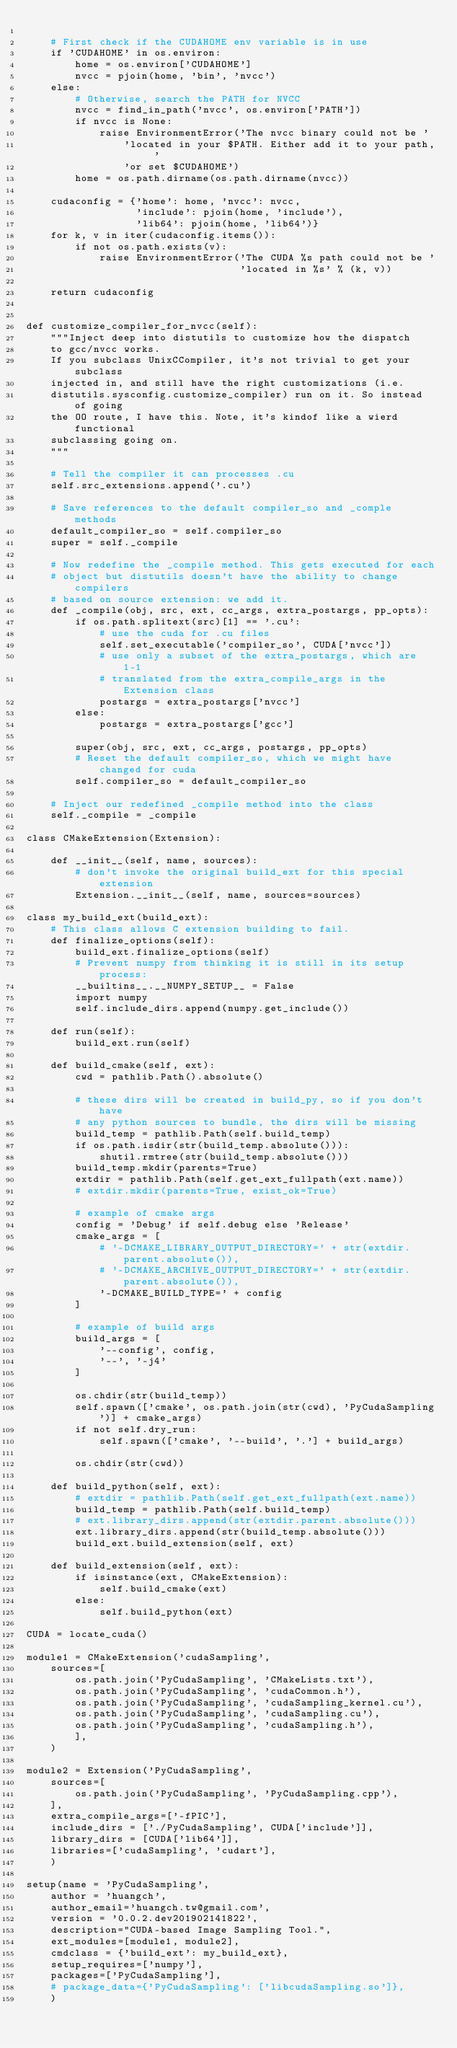Convert code to text. <code><loc_0><loc_0><loc_500><loc_500><_Python_>
    # First check if the CUDAHOME env variable is in use
    if 'CUDAHOME' in os.environ:
        home = os.environ['CUDAHOME']
        nvcc = pjoin(home, 'bin', 'nvcc')
    else:
        # Otherwise, search the PATH for NVCC
        nvcc = find_in_path('nvcc', os.environ['PATH'])
        if nvcc is None:
            raise EnvironmentError('The nvcc binary could not be '
                'located in your $PATH. Either add it to your path, '
                'or set $CUDAHOME')
        home = os.path.dirname(os.path.dirname(nvcc))

    cudaconfig = {'home': home, 'nvcc': nvcc,
                  'include': pjoin(home, 'include'),
                  'lib64': pjoin(home, 'lib64')}
    for k, v in iter(cudaconfig.items()):
        if not os.path.exists(v):
            raise EnvironmentError('The CUDA %s path could not be '
                                   'located in %s' % (k, v))

    return cudaconfig


def customize_compiler_for_nvcc(self):
    """Inject deep into distutils to customize how the dispatch
    to gcc/nvcc works.
    If you subclass UnixCCompiler, it's not trivial to get your subclass
    injected in, and still have the right customizations (i.e.
    distutils.sysconfig.customize_compiler) run on it. So instead of going
    the OO route, I have this. Note, it's kindof like a wierd functional
    subclassing going on.
    """

    # Tell the compiler it can processes .cu
    self.src_extensions.append('.cu')

    # Save references to the default compiler_so and _comple methods
    default_compiler_so = self.compiler_so
    super = self._compile

    # Now redefine the _compile method. This gets executed for each
    # object but distutils doesn't have the ability to change compilers
    # based on source extension: we add it.
    def _compile(obj, src, ext, cc_args, extra_postargs, pp_opts):
        if os.path.splitext(src)[1] == '.cu':
            # use the cuda for .cu files
            self.set_executable('compiler_so', CUDA['nvcc'])
            # use only a subset of the extra_postargs, which are 1-1
            # translated from the extra_compile_args in the Extension class
            postargs = extra_postargs['nvcc']
        else:
            postargs = extra_postargs['gcc']

        super(obj, src, ext, cc_args, postargs, pp_opts)
        # Reset the default compiler_so, which we might have changed for cuda
        self.compiler_so = default_compiler_so

    # Inject our redefined _compile method into the class
    self._compile = _compile
    
class CMakeExtension(Extension):

    def __init__(self, name, sources):
        # don't invoke the original build_ext for this special extension
        Extension.__init__(self, name, sources=sources)

class my_build_ext(build_ext):
    # This class allows C extension building to fail.
    def finalize_options(self):
        build_ext.finalize_options(self)
        # Prevent numpy from thinking it is still in its setup process:
        __builtins__.__NUMPY_SETUP__ = False
        import numpy
        self.include_dirs.append(numpy.get_include())

    def run(self):
        build_ext.run(self)

    def build_cmake(self, ext):
        cwd = pathlib.Path().absolute()

        # these dirs will be created in build_py, so if you don't have
        # any python sources to bundle, the dirs will be missing
        build_temp = pathlib.Path(self.build_temp)
        if os.path.isdir(str(build_temp.absolute())):
            shutil.rmtree(str(build_temp.absolute()))
        build_temp.mkdir(parents=True)
        extdir = pathlib.Path(self.get_ext_fullpath(ext.name))
        # extdir.mkdir(parents=True, exist_ok=True)

        # example of cmake args
        config = 'Debug' if self.debug else 'Release'
        cmake_args = [
            # '-DCMAKE_LIBRARY_OUTPUT_DIRECTORY=' + str(extdir.parent.absolute()),
            # '-DCMAKE_ARCHIVE_OUTPUT_DIRECTORY=' + str(extdir.parent.absolute()),
            '-DCMAKE_BUILD_TYPE=' + config
        ]

        # example of build args
        build_args = [
            '--config', config,
            '--', '-j4'
        ]

        os.chdir(str(build_temp))        
        self.spawn(['cmake', os.path.join(str(cwd), 'PyCudaSampling')] + cmake_args)
        if not self.dry_run:
            self.spawn(['cmake', '--build', '.'] + build_args)
            
        os.chdir(str(cwd))
        
    def build_python(self, ext):
        # extdir = pathlib.Path(self.get_ext_fullpath(ext.name))
        build_temp = pathlib.Path(self.build_temp)
        # ext.library_dirs.append(str(extdir.parent.absolute()))
        ext.library_dirs.append(str(build_temp.absolute()))
        build_ext.build_extension(self, ext)
        
    def build_extension(self, ext):
        if isinstance(ext, CMakeExtension):
            self.build_cmake(ext)
        else:
            self.build_python(ext)
      
CUDA = locate_cuda()

module1 = CMakeExtension('cudaSampling',
    sources=[
        os.path.join('PyCudaSampling', 'CMakeLists.txt'),
        os.path.join('PyCudaSampling', 'cudaCommon.h'),
        os.path.join('PyCudaSampling', 'cudaSampling_kernel.cu'),
        os.path.join('PyCudaSampling', 'cudaSampling.cu'),
        os.path.join('PyCudaSampling', 'cudaSampling.h'),
        ],
    )
  
module2 = Extension('PyCudaSampling',
    sources=[
        os.path.join('PyCudaSampling', 'PyCudaSampling.cpp'),
    ],
    extra_compile_args=['-fPIC'],
    include_dirs = ['./PyCudaSampling', CUDA['include']],
    library_dirs = [CUDA['lib64']],
    libraries=['cudaSampling', 'cudart'],
    )      
      
setup(name = 'PyCudaSampling',
    author = 'huangch', 
    author_email='huangch.tw@gmail.com',
    version = '0.0.2.dev201902141822',
    description="CUDA-based Image Sampling Tool.",
    ext_modules=[module1, module2],
    cmdclass = {'build_ext': my_build_ext},
    setup_requires=['numpy'],
    packages=['PyCudaSampling'],
    # package_data={'PyCudaSampling': ['libcudaSampling.so']},
    )
</code> 